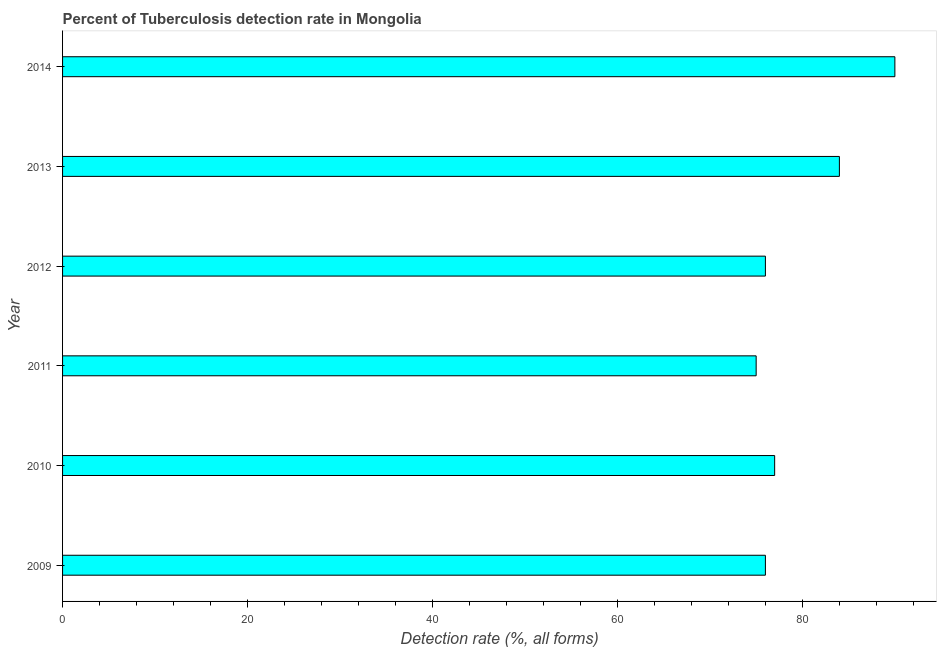Does the graph contain grids?
Provide a short and direct response. No. What is the title of the graph?
Your answer should be compact. Percent of Tuberculosis detection rate in Mongolia. What is the label or title of the X-axis?
Offer a terse response. Detection rate (%, all forms). Across all years, what is the maximum detection rate of tuberculosis?
Provide a short and direct response. 90. Across all years, what is the minimum detection rate of tuberculosis?
Keep it short and to the point. 75. In which year was the detection rate of tuberculosis minimum?
Provide a succinct answer. 2011. What is the sum of the detection rate of tuberculosis?
Ensure brevity in your answer.  478. What is the average detection rate of tuberculosis per year?
Your answer should be compact. 79. What is the median detection rate of tuberculosis?
Ensure brevity in your answer.  76.5. In how many years, is the detection rate of tuberculosis greater than 48 %?
Your response must be concise. 6. What is the ratio of the detection rate of tuberculosis in 2012 to that in 2013?
Ensure brevity in your answer.  0.91. Is the detection rate of tuberculosis in 2009 less than that in 2011?
Keep it short and to the point. No. What is the difference between the highest and the lowest detection rate of tuberculosis?
Keep it short and to the point. 15. In how many years, is the detection rate of tuberculosis greater than the average detection rate of tuberculosis taken over all years?
Offer a terse response. 2. How many years are there in the graph?
Make the answer very short. 6. What is the Detection rate (%, all forms) in 2010?
Make the answer very short. 77. What is the Detection rate (%, all forms) of 2011?
Offer a very short reply. 75. What is the Detection rate (%, all forms) of 2012?
Offer a terse response. 76. What is the Detection rate (%, all forms) of 2013?
Your response must be concise. 84. What is the Detection rate (%, all forms) of 2014?
Provide a succinct answer. 90. What is the difference between the Detection rate (%, all forms) in 2009 and 2011?
Ensure brevity in your answer.  1. What is the difference between the Detection rate (%, all forms) in 2009 and 2012?
Keep it short and to the point. 0. What is the difference between the Detection rate (%, all forms) in 2009 and 2013?
Ensure brevity in your answer.  -8. What is the difference between the Detection rate (%, all forms) in 2010 and 2011?
Make the answer very short. 2. What is the difference between the Detection rate (%, all forms) in 2010 and 2012?
Your answer should be very brief. 1. What is the difference between the Detection rate (%, all forms) in 2011 and 2012?
Offer a terse response. -1. What is the difference between the Detection rate (%, all forms) in 2011 and 2013?
Ensure brevity in your answer.  -9. What is the difference between the Detection rate (%, all forms) in 2011 and 2014?
Give a very brief answer. -15. What is the difference between the Detection rate (%, all forms) in 2012 and 2013?
Give a very brief answer. -8. What is the difference between the Detection rate (%, all forms) in 2012 and 2014?
Offer a terse response. -14. What is the difference between the Detection rate (%, all forms) in 2013 and 2014?
Offer a terse response. -6. What is the ratio of the Detection rate (%, all forms) in 2009 to that in 2012?
Offer a terse response. 1. What is the ratio of the Detection rate (%, all forms) in 2009 to that in 2013?
Offer a very short reply. 0.91. What is the ratio of the Detection rate (%, all forms) in 2009 to that in 2014?
Your answer should be very brief. 0.84. What is the ratio of the Detection rate (%, all forms) in 2010 to that in 2011?
Provide a short and direct response. 1.03. What is the ratio of the Detection rate (%, all forms) in 2010 to that in 2013?
Provide a short and direct response. 0.92. What is the ratio of the Detection rate (%, all forms) in 2010 to that in 2014?
Offer a terse response. 0.86. What is the ratio of the Detection rate (%, all forms) in 2011 to that in 2013?
Provide a succinct answer. 0.89. What is the ratio of the Detection rate (%, all forms) in 2011 to that in 2014?
Keep it short and to the point. 0.83. What is the ratio of the Detection rate (%, all forms) in 2012 to that in 2013?
Keep it short and to the point. 0.91. What is the ratio of the Detection rate (%, all forms) in 2012 to that in 2014?
Provide a short and direct response. 0.84. What is the ratio of the Detection rate (%, all forms) in 2013 to that in 2014?
Your answer should be very brief. 0.93. 